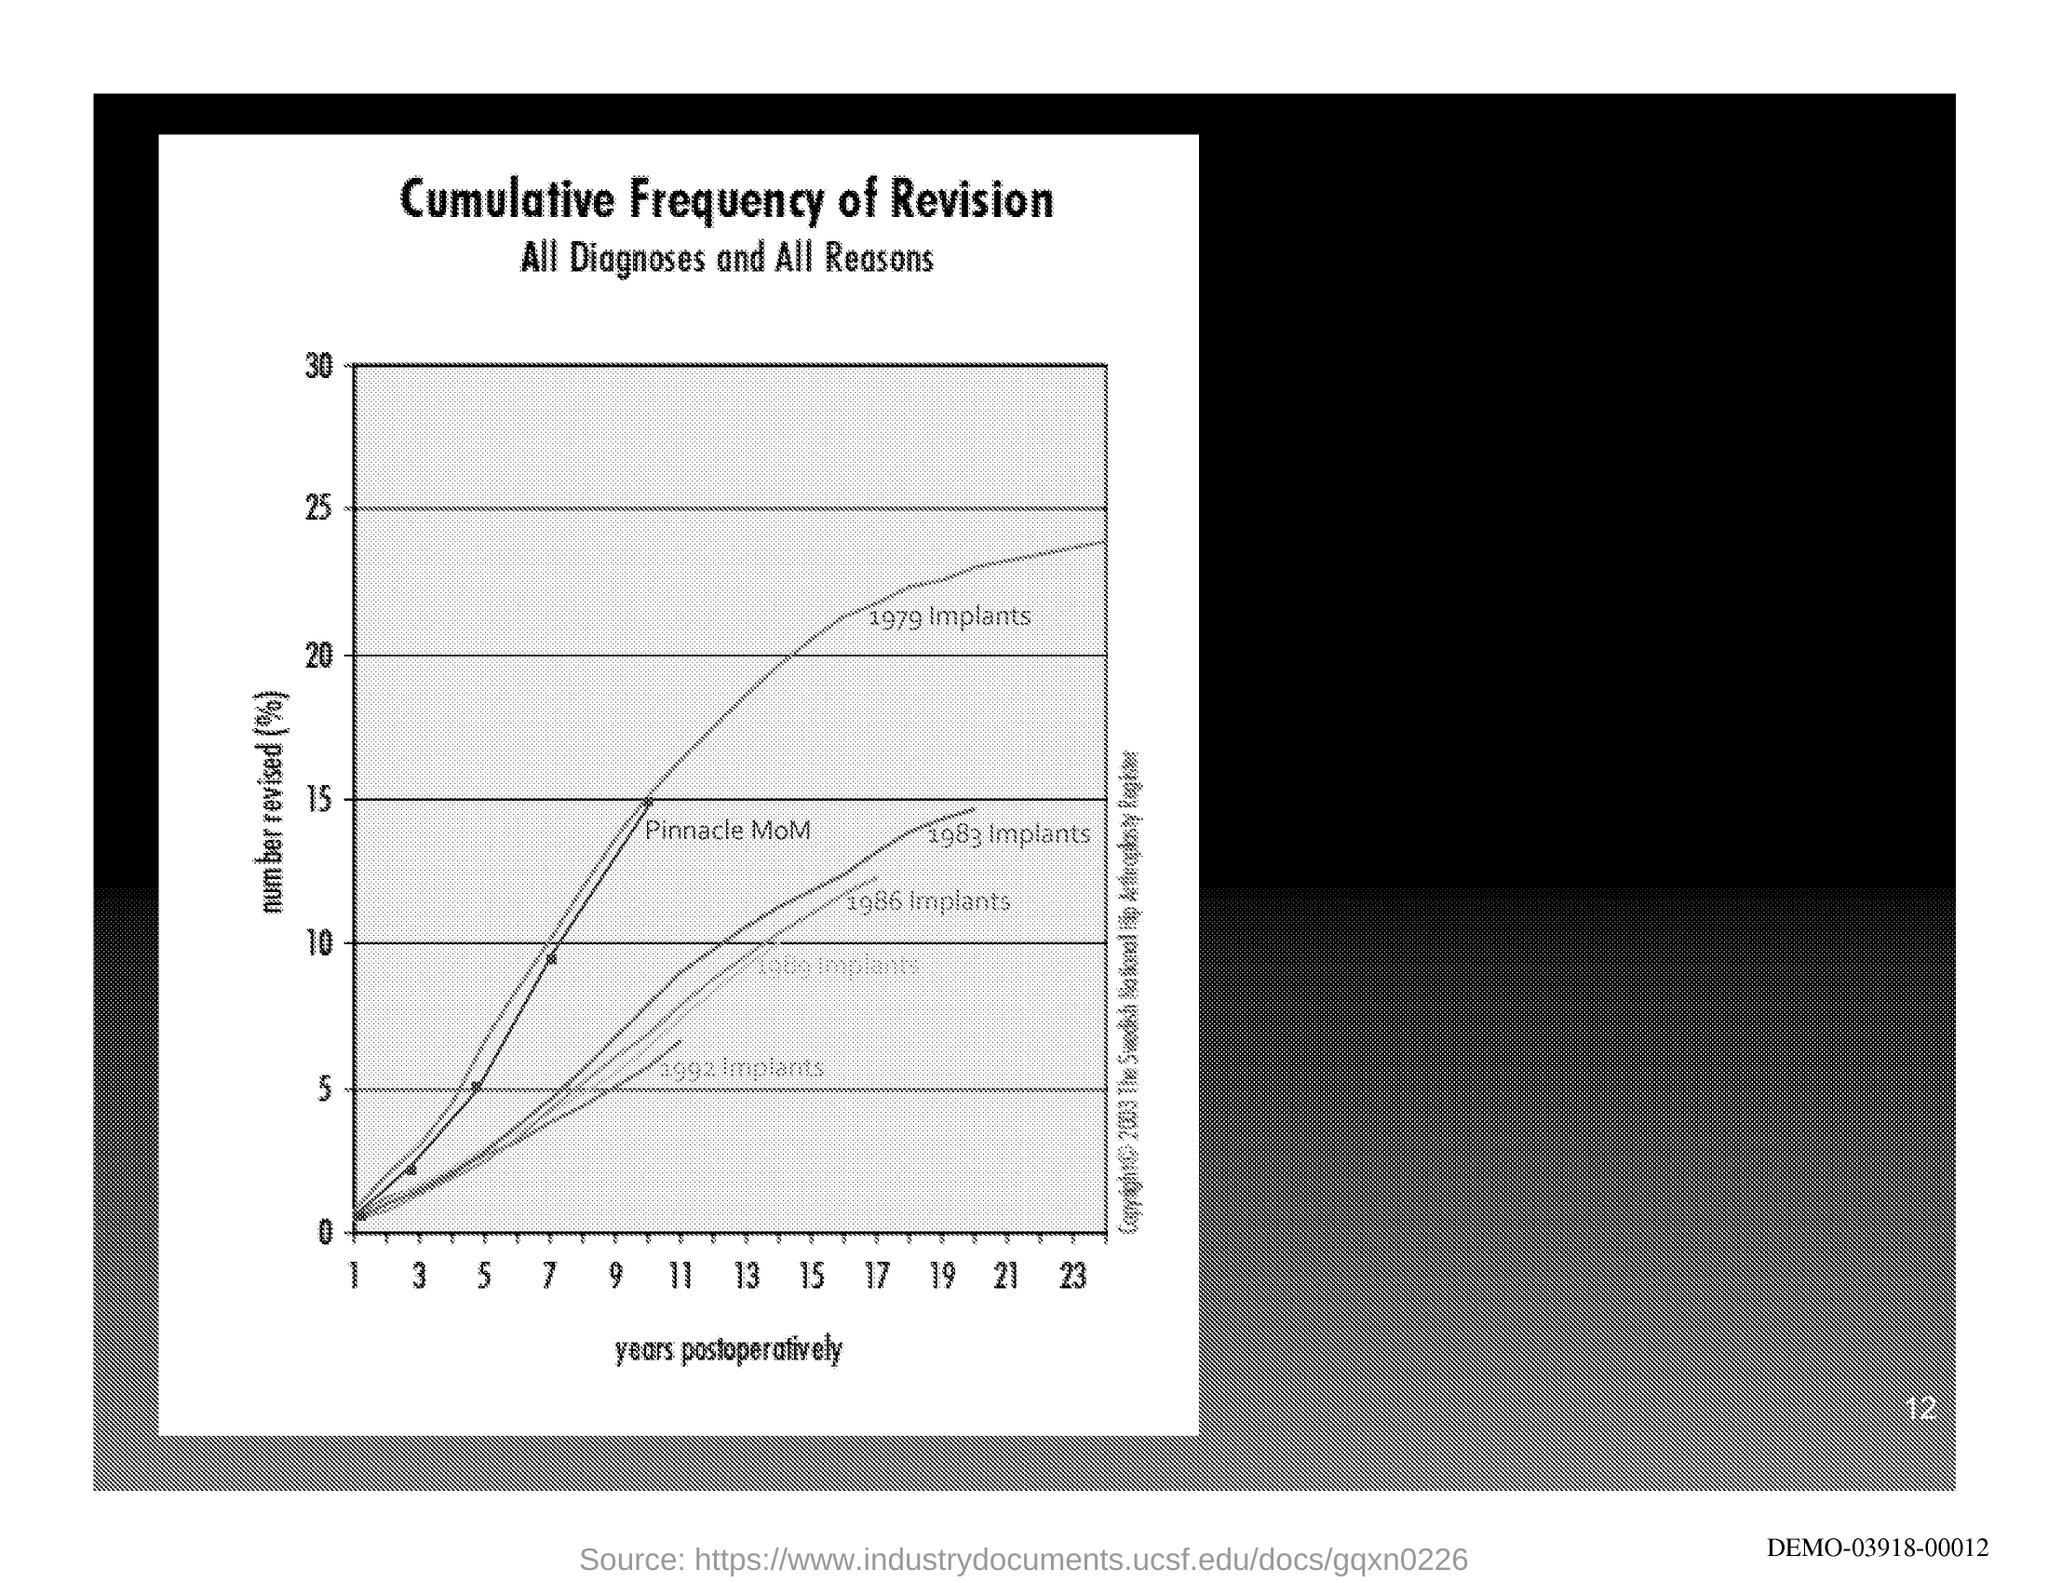What is the first title in the document?
Provide a succinct answer. Cumulative Frequency of Revision. What is the second title in the document?
Provide a short and direct response. All Diagnoses and All Reasons. What is the Page Number?
Keep it short and to the point. 12. What is plotted on the x-axis?
Offer a terse response. Years postoperatively. 